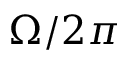<formula> <loc_0><loc_0><loc_500><loc_500>\Omega / 2 \pi</formula> 